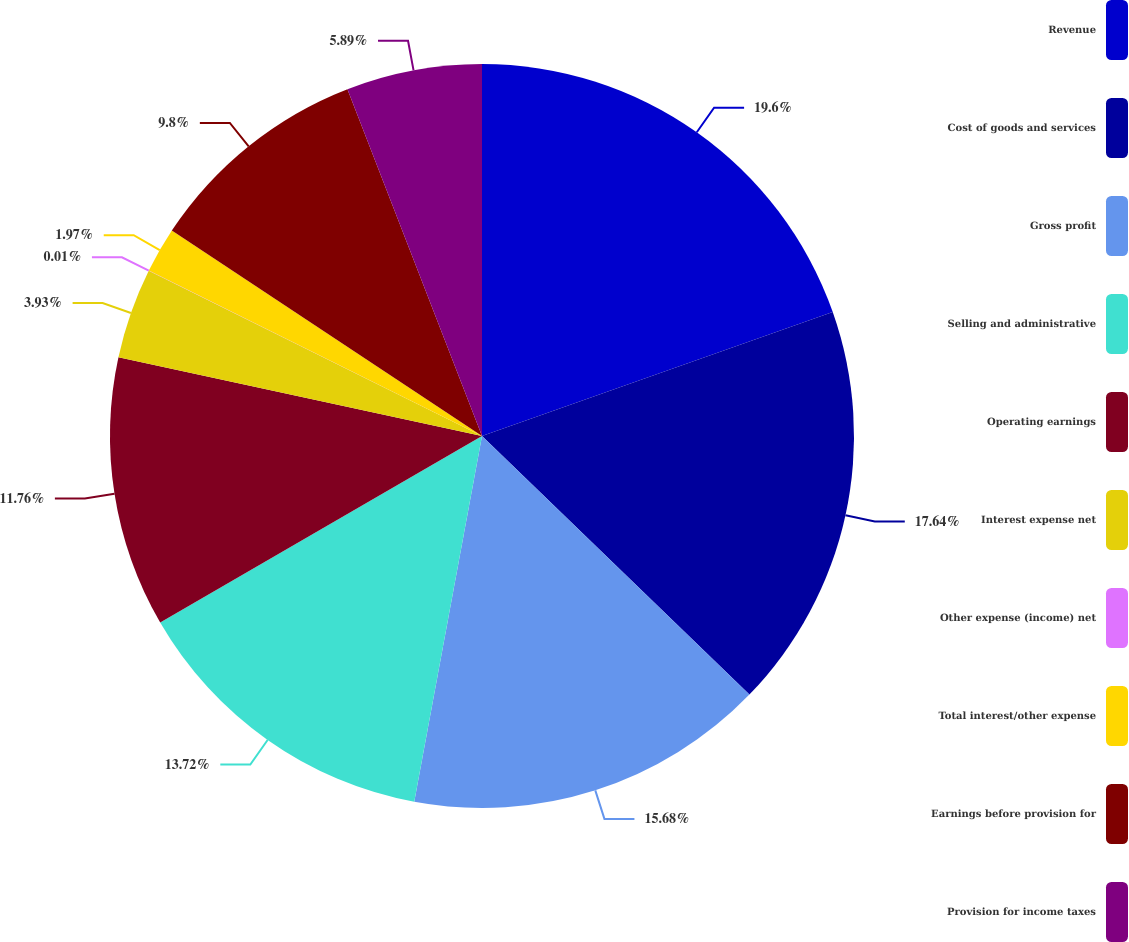Convert chart to OTSL. <chart><loc_0><loc_0><loc_500><loc_500><pie_chart><fcel>Revenue<fcel>Cost of goods and services<fcel>Gross profit<fcel>Selling and administrative<fcel>Operating earnings<fcel>Interest expense net<fcel>Other expense (income) net<fcel>Total interest/other expense<fcel>Earnings before provision for<fcel>Provision for income taxes<nl><fcel>19.59%<fcel>17.64%<fcel>15.68%<fcel>13.72%<fcel>11.76%<fcel>3.93%<fcel>0.01%<fcel>1.97%<fcel>9.8%<fcel>5.89%<nl></chart> 